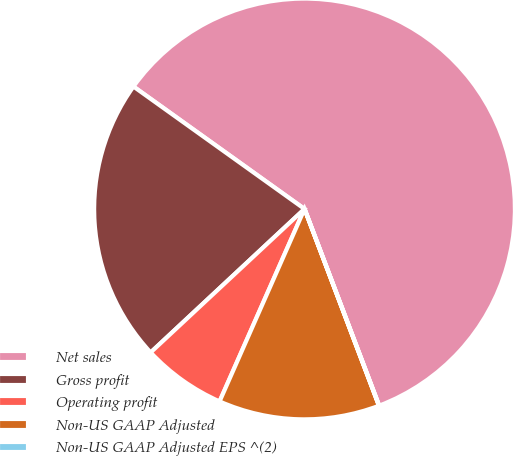Convert chart. <chart><loc_0><loc_0><loc_500><loc_500><pie_chart><fcel>Net sales<fcel>Gross profit<fcel>Operating profit<fcel>Non-US GAAP Adjusted<fcel>Non-US GAAP Adjusted EPS ^(2)<nl><fcel>59.34%<fcel>21.83%<fcel>6.44%<fcel>12.37%<fcel>0.02%<nl></chart> 